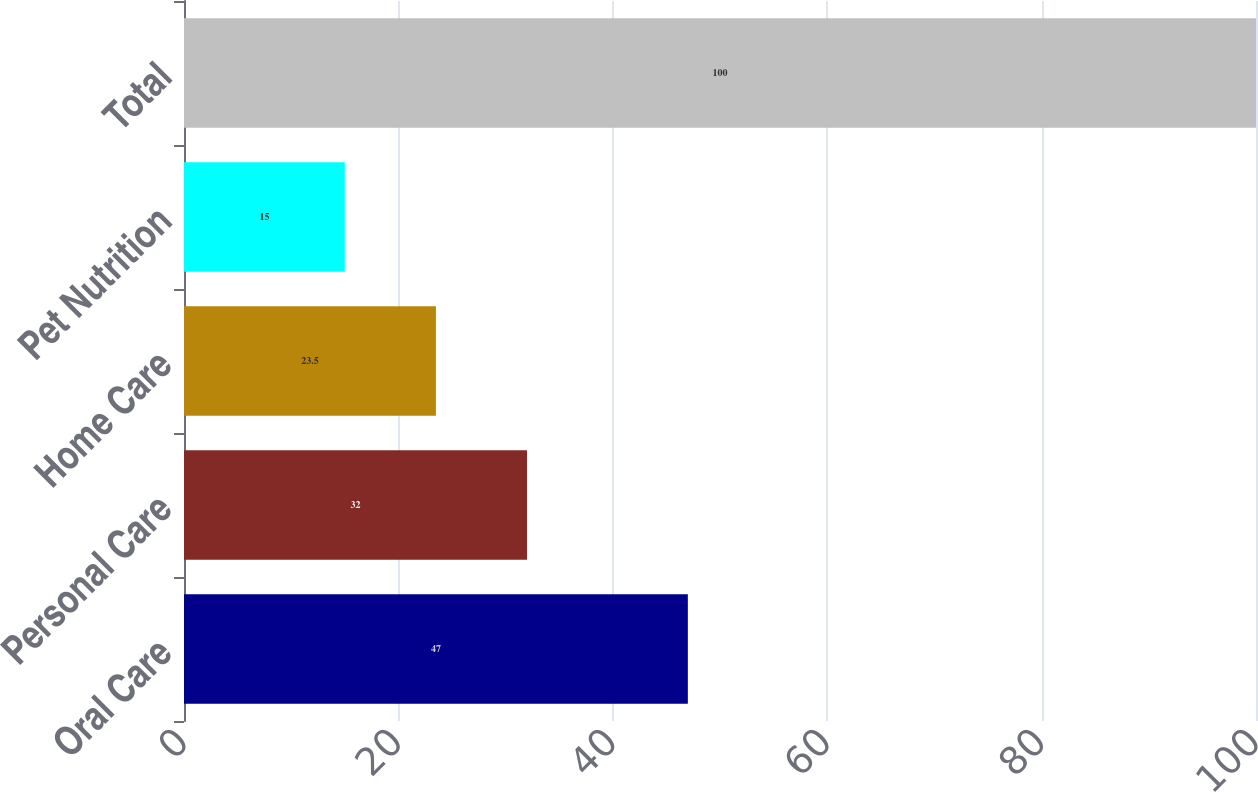Convert chart to OTSL. <chart><loc_0><loc_0><loc_500><loc_500><bar_chart><fcel>Oral Care<fcel>Personal Care<fcel>Home Care<fcel>Pet Nutrition<fcel>Total<nl><fcel>47<fcel>32<fcel>23.5<fcel>15<fcel>100<nl></chart> 